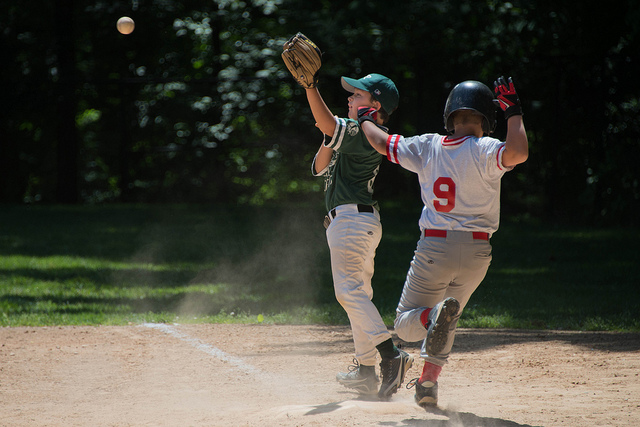Read and extract the text from this image. 9 